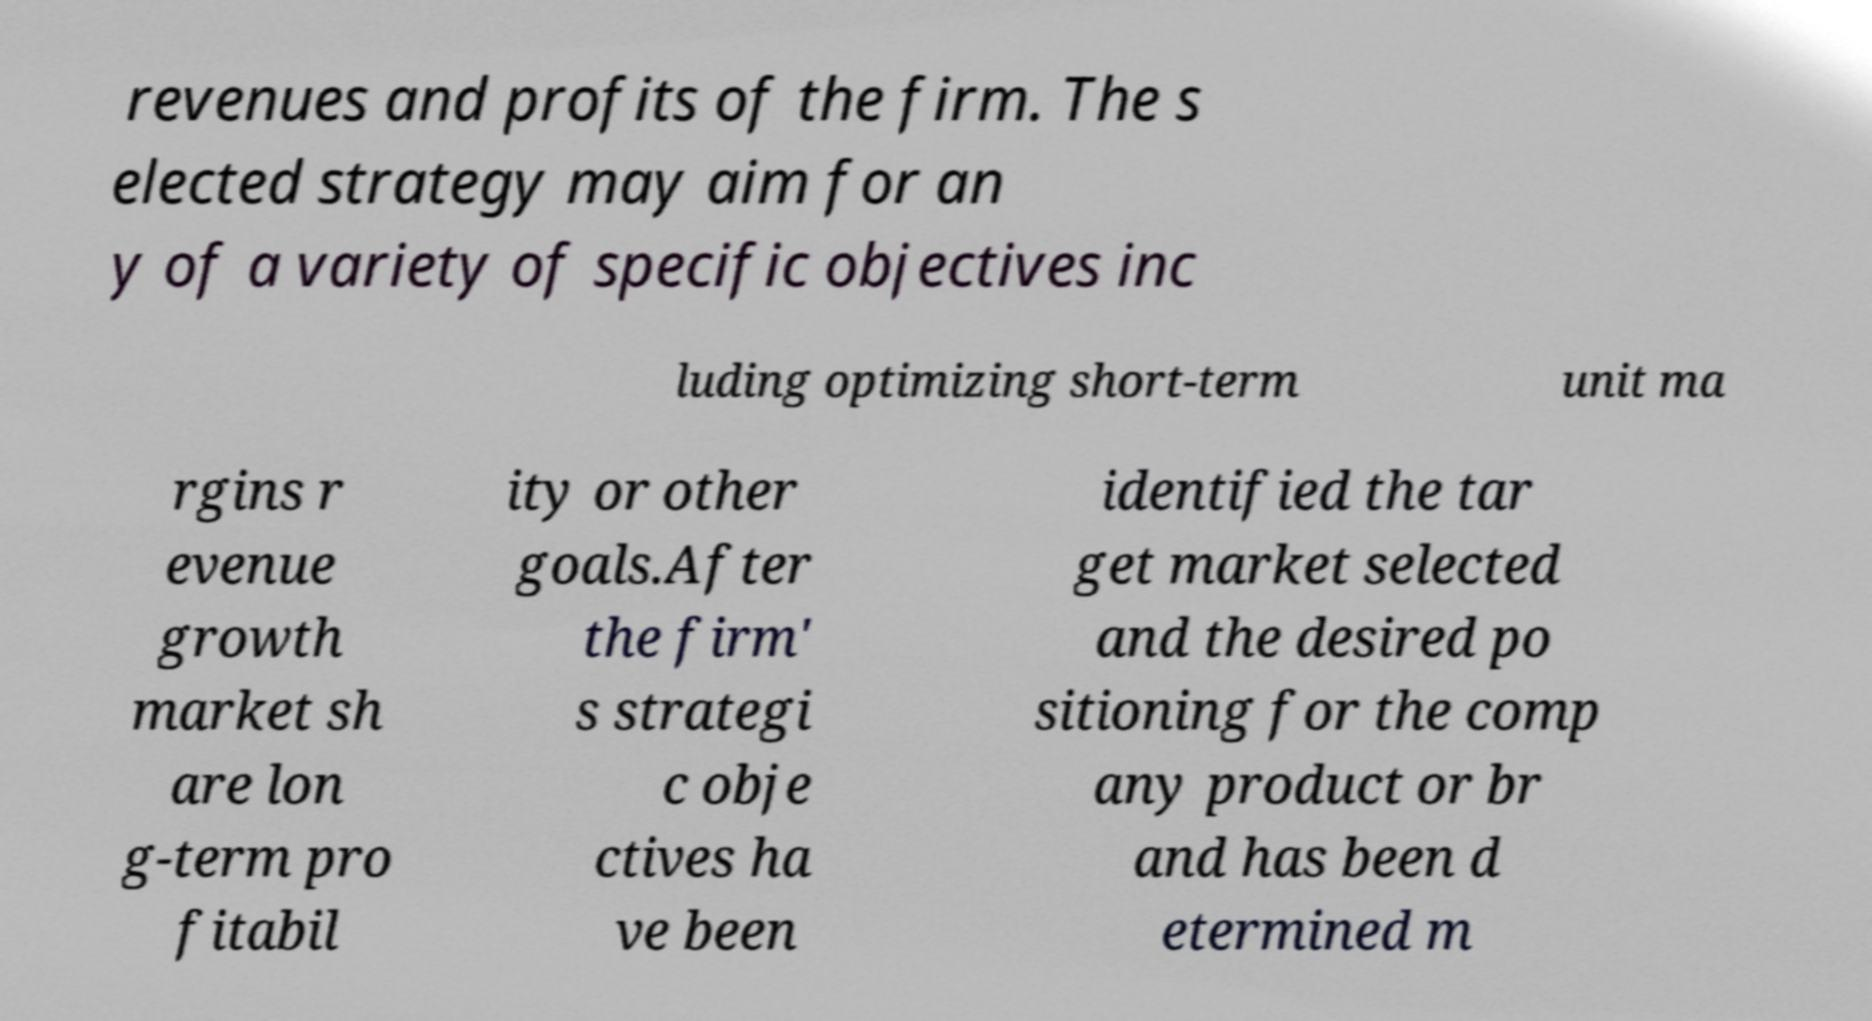Please identify and transcribe the text found in this image. revenues and profits of the firm. The s elected strategy may aim for an y of a variety of specific objectives inc luding optimizing short-term unit ma rgins r evenue growth market sh are lon g-term pro fitabil ity or other goals.After the firm' s strategi c obje ctives ha ve been identified the tar get market selected and the desired po sitioning for the comp any product or br and has been d etermined m 